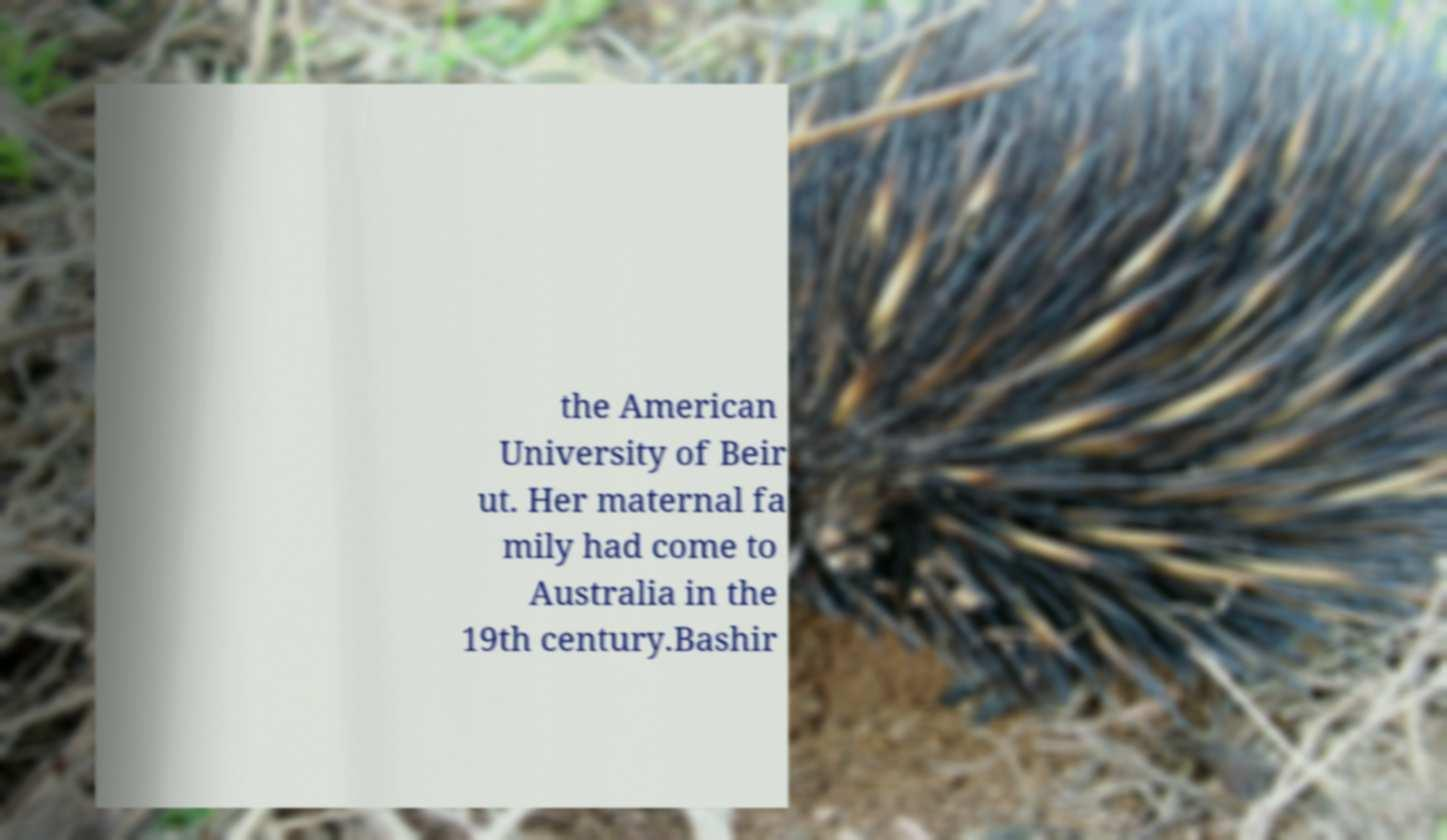Can you accurately transcribe the text from the provided image for me? the American University of Beir ut. Her maternal fa mily had come to Australia in the 19th century.Bashir 